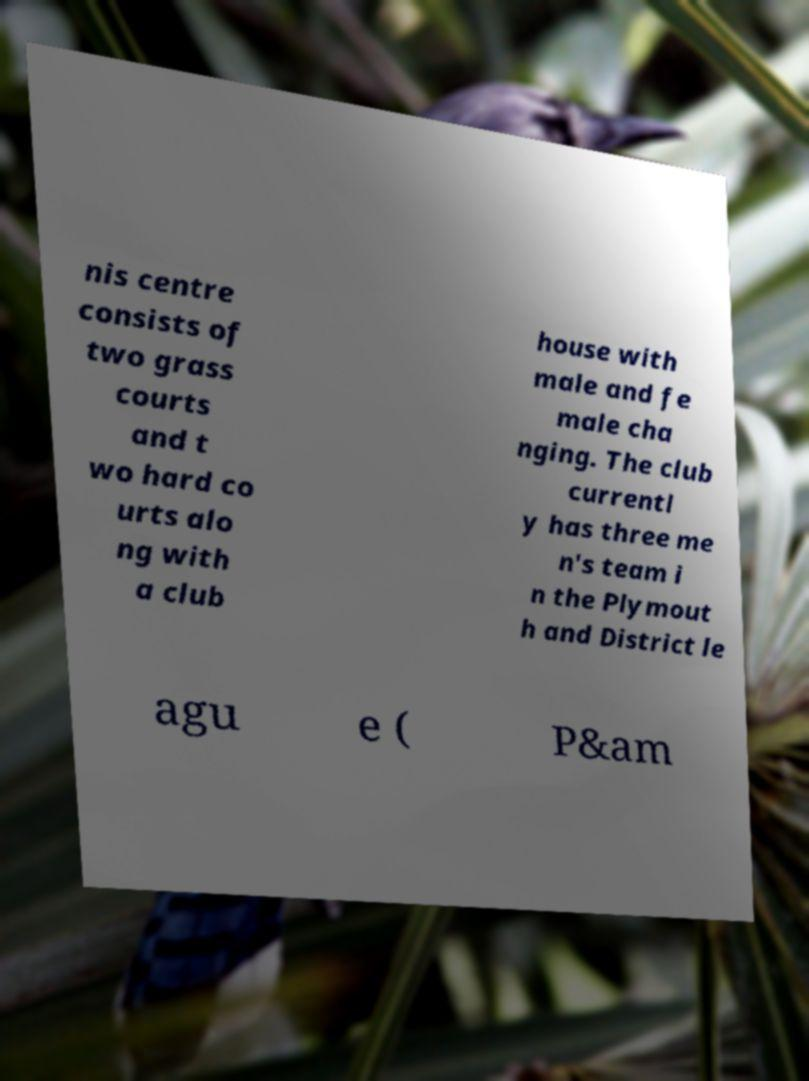I need the written content from this picture converted into text. Can you do that? nis centre consists of two grass courts and t wo hard co urts alo ng with a club house with male and fe male cha nging. The club currentl y has three me n's team i n the Plymout h and District le agu e ( P&am 